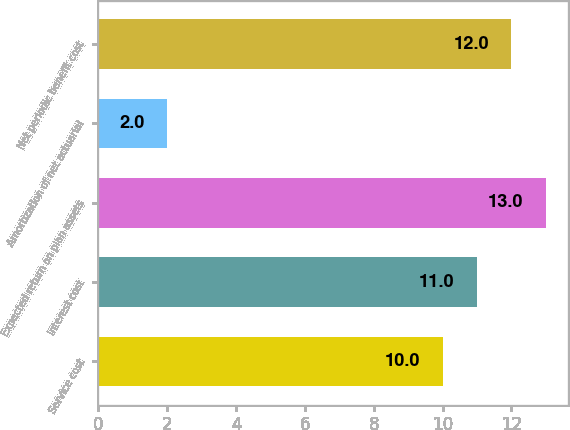<chart> <loc_0><loc_0><loc_500><loc_500><bar_chart><fcel>Service cost<fcel>Interest cost<fcel>Expected return on plan assets<fcel>Amortization of net actuarial<fcel>Net periodic benefit cost<nl><fcel>10<fcel>11<fcel>13<fcel>2<fcel>12<nl></chart> 